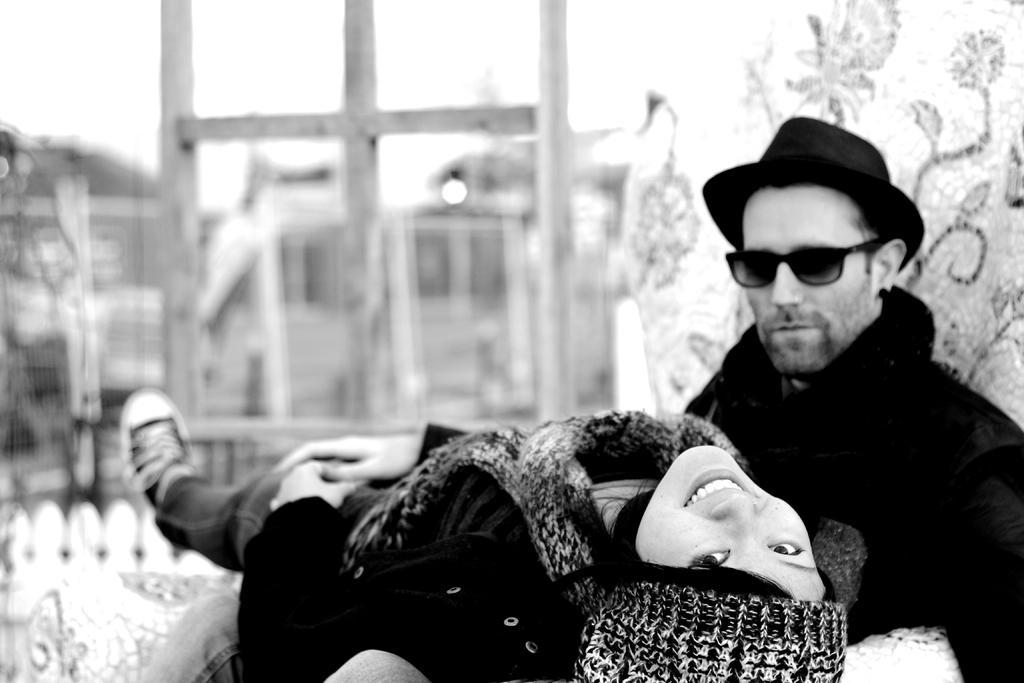In one or two sentences, can you explain what this image depicts? In this picture we can see a man and a woman, they wore caps, this man wore goggles, there is a blurry background. 